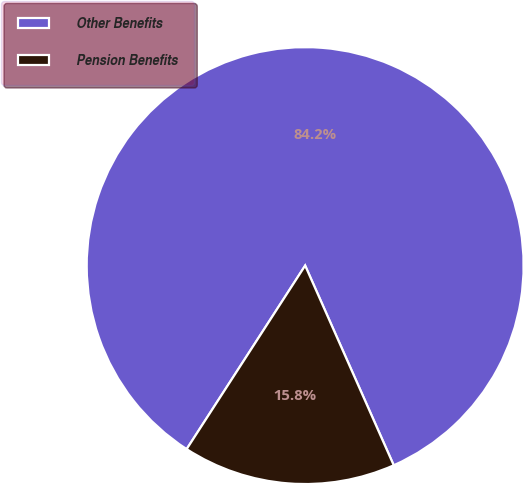<chart> <loc_0><loc_0><loc_500><loc_500><pie_chart><fcel>Other Benefits<fcel>Pension Benefits<nl><fcel>84.23%<fcel>15.77%<nl></chart> 